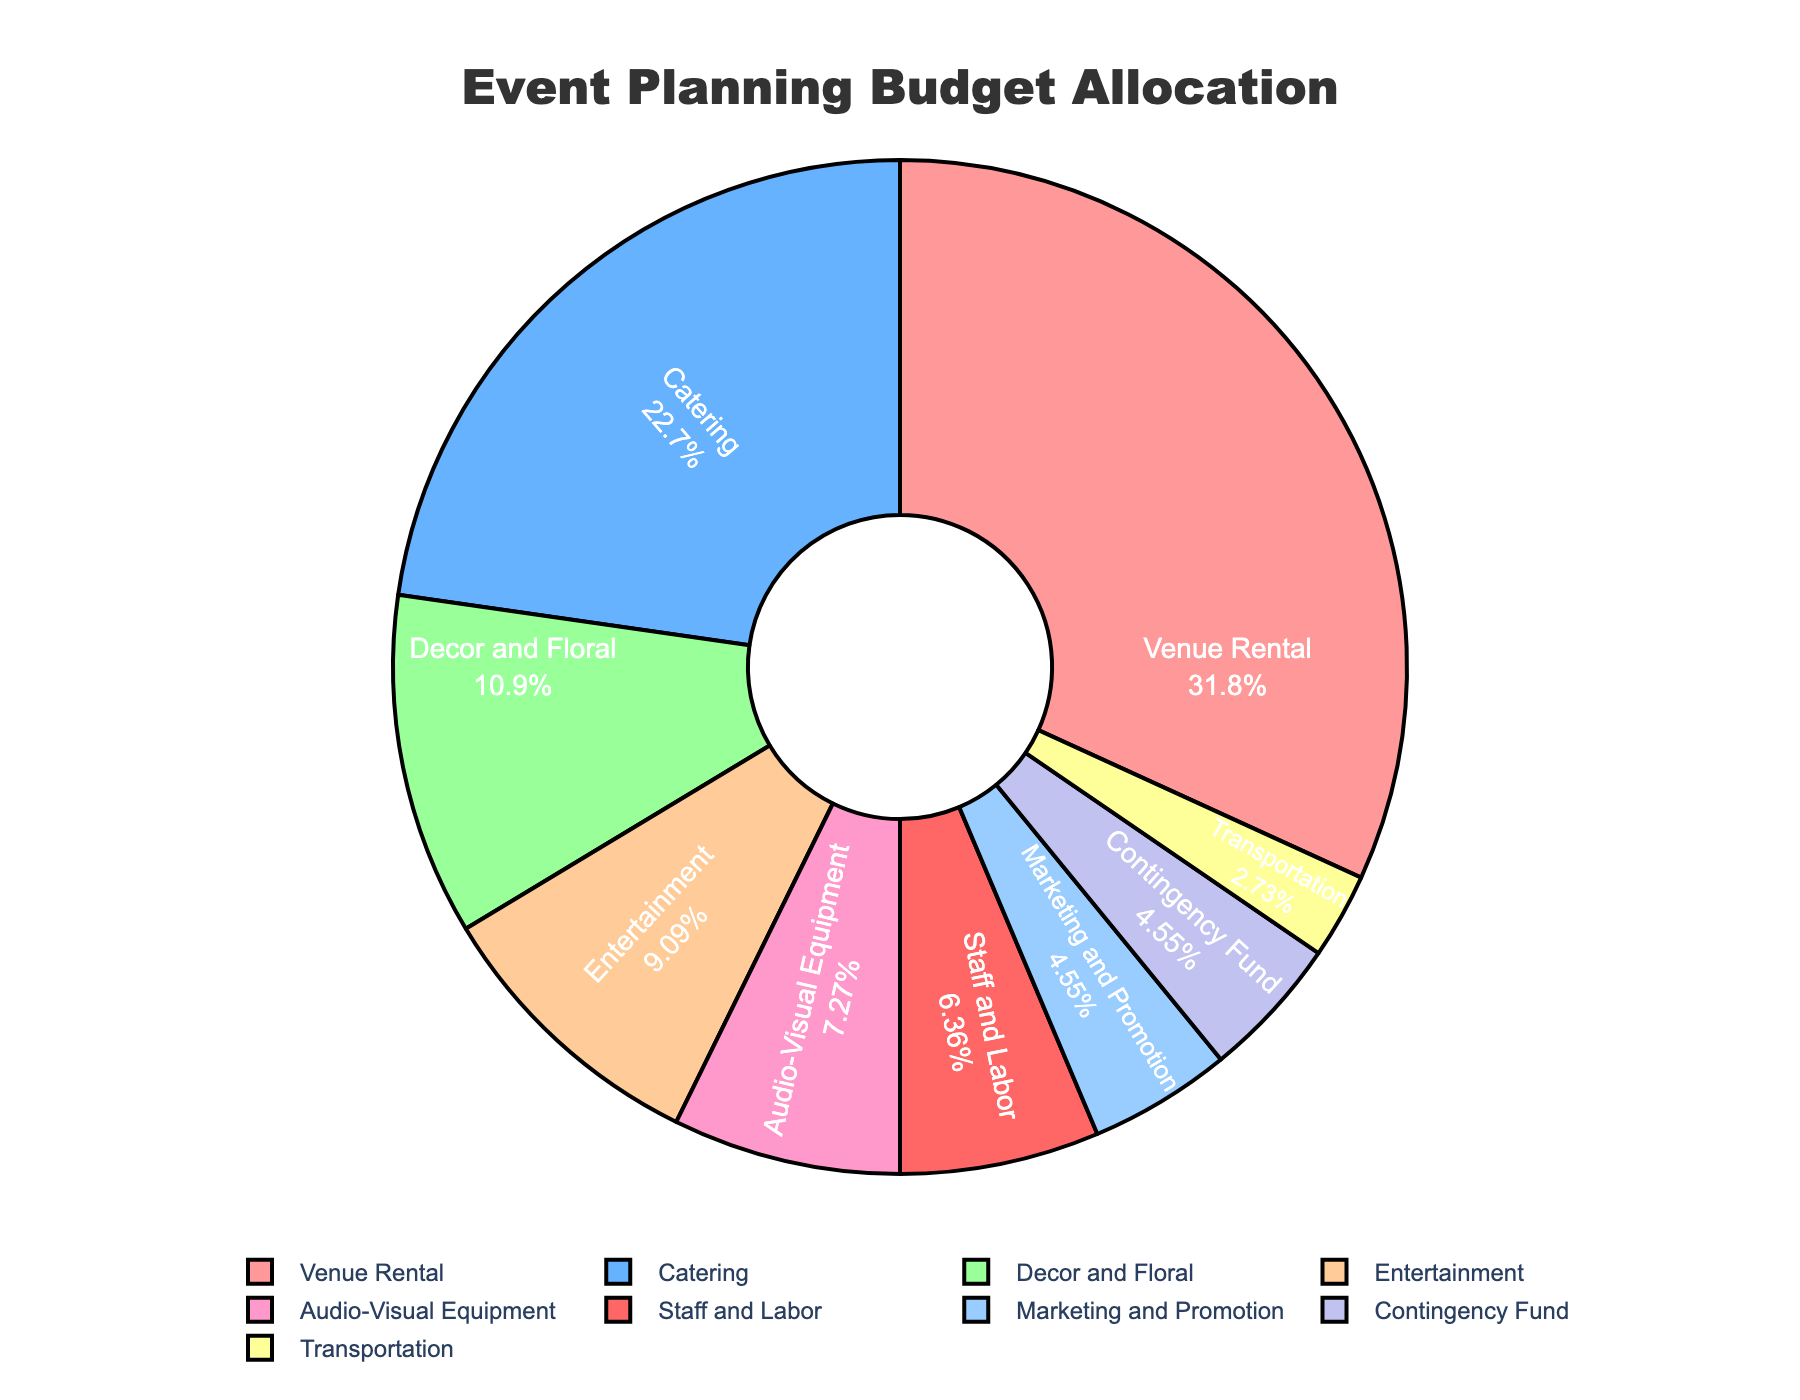What's the total percentage allocated to Catering and Venue Rental? To find the total percentage allocated to Catering and Venue Rental, sum the percentages for these two categories: 25% for Catering and 35% for Venue Rental. 25 + 35 = 60
Answer: 60 Which category has the smallest allocation? Look at the pie chart to identify the category with the smallest percentage. Transportation has 3%, the smallest allocation.
Answer: Transportation How much more percentage is allocated to Decor and Floral than Marketing and Promotion? Subtract the percentage of Marketing and Promotion from the percentage of Decor and Floral: 12% - 5% = 7%
Answer: 7 Which two categories combined have more than half the budget allocation, and what is their combined percentage? Identify the two categories with the highest percentages. Venue Rental and Catering have 35% and 25%, respectively. Sum their percentages: 35 + 25 = 60. Their combined percentage is 60%, which is more than half of the budget.
Answer: Venue Rental and Catering, 60% Is the budget allocated to Audio-Visual Equipment greater than, less than, or equal to the budget allocated to the Contingency Fund? Compare the percentages of Audio-Visual Equipment and the Contingency Fund. Audio-Visual Equipment has 8%, and the Contingency Fund has 5%. 8% is greater than 5%.
Answer: Greater than What's the average percentage allocated to Staff and Labor, Transportation, and Marketing and Promotion? To find the average, sum the percentages for these three categories and then divide by 3. Staff and Labor: 7%, Transportation: 3%, Marketing and Promotion: 5%. (7 + 3 + 5)/3 = 15/3 = 5
Answer: 5 Which categories have a lower budget allocation than Audio-Visual Equipment? Compare the percentages of all categories with that of Audio-Visual Equipment (8%). Categories with lower percentages are Decor and Floral (12%), Transportation (3%), Marketing and Promotion (5%), Staff and Labor (7%), and Contingency Fund (5%).
Answer: Catering, Transportation, Marketing and Promotion, Staff and Labor, Contingency Fund What's the difference in percentage between the highest and lowest budget allocation categories? Identify the highest (Venue Rental at 35%) and the lowest (Transportation at 3%) percentages and subtract the lowest from the highest: 35 - 3 = 32
Answer: 32 Which categories have an allocation percentage in the range of 5% to 10%? Look for categories whose percentages fall within 5% and 10%. They are Audio-Visual Equipment (8%), Marketing and Promotion (5%), Staff and Labor (7%), and Entertainment (10%).
Answer: Audio-Visual Equipment, Marketing and Promotion, Staff and Labor, Entertainment What is the combined percentage allocation for Entertainment and Transport and how does it compare to the allocation for Decor and Floral? Sum the percentages for Entertainment (10%) and Transport (3%): 10 + 3 = 13. Compare this with Decor and Floral’s percentage (12%). The combined percentage (13%) is greater than Decor and Floral’s percentage (12%).
Answer: 13, greater than Decor and Floral 